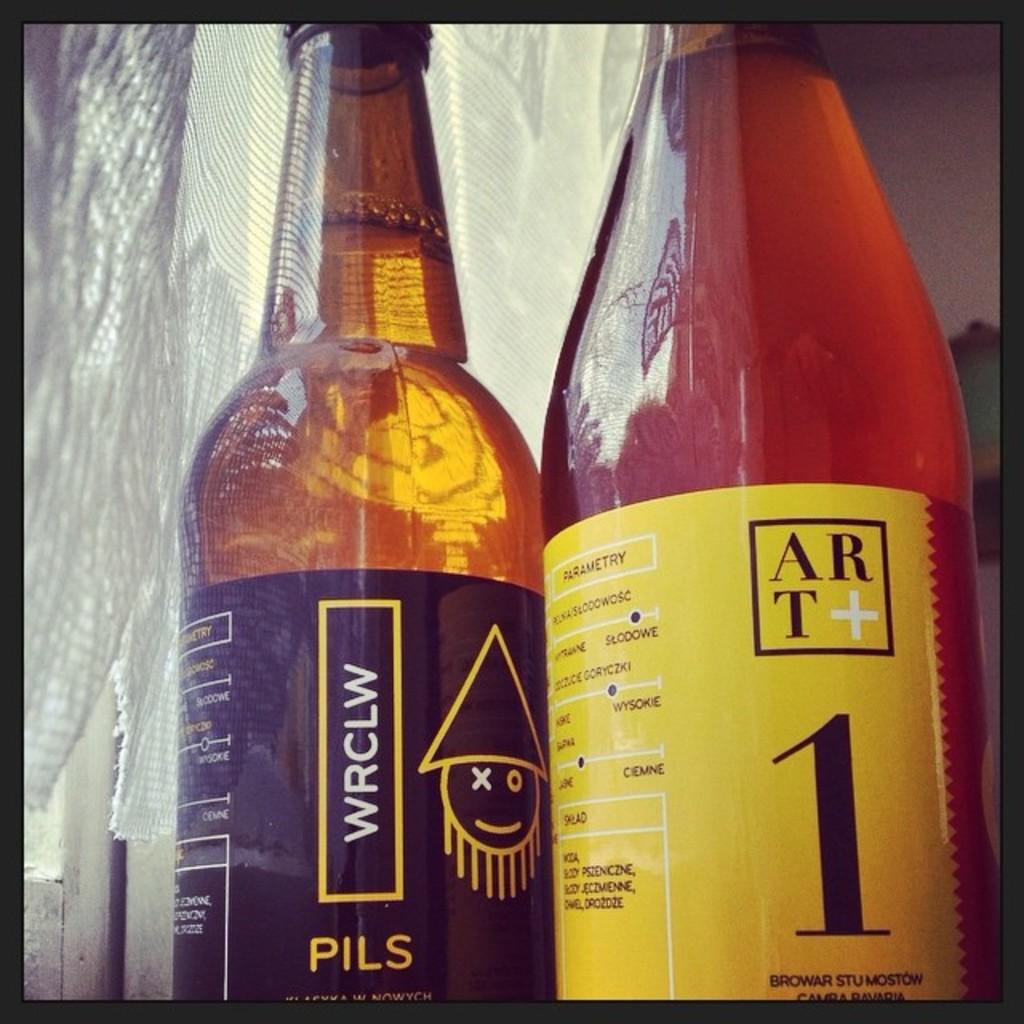What number is displayed on the right bottle?
Make the answer very short. 1. 